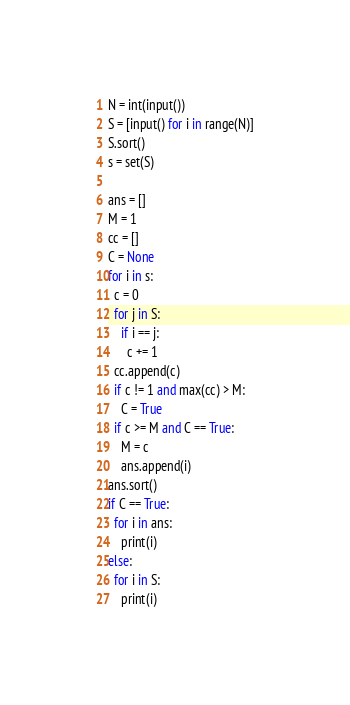Convert code to text. <code><loc_0><loc_0><loc_500><loc_500><_Python_>N = int(input())
S = [input() for i in range(N)]
S.sort()
s = set(S)

ans = []
M = 1
cc = []
C = None
for i in s:
  c = 0
  for j in S:
    if i == j:
      c += 1
  cc.append(c)
  if c != 1 and max(cc) > M:
    C = True
  if c >= M and C == True:
    M = c
    ans.append(i)
ans.sort()
if C == True:
  for i in ans:
    print(i)
else:
  for i in S:
    print(i)</code> 